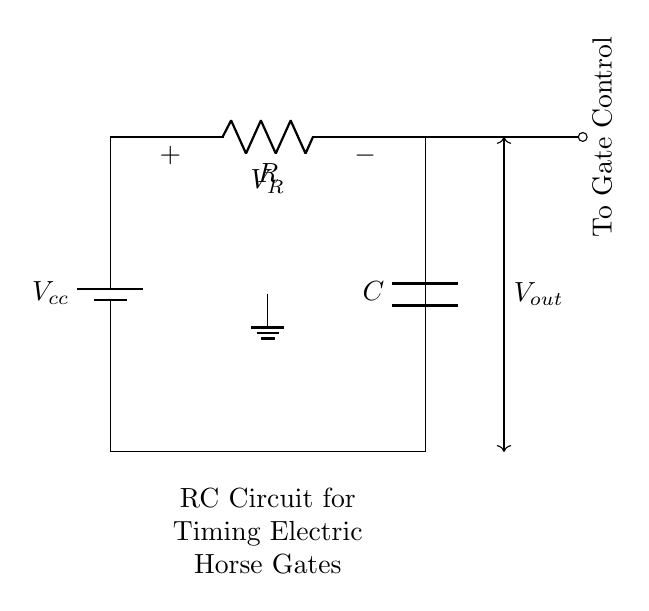What is the voltage source in this circuit? The circuit contains a battery labeled as Vcc, which provides the voltage for the circuit. It is clearly depicted as a vertical source at the left side of the diagram.
Answer: Vcc What component is used to control timing in this circuit? The capacitor labeled as C is used to store charge and control timing. In RC circuits, the capacitor discharges through the resistor, creating a timing effect.
Answer: C What is the voltage across the resistor? The voltage across the resistor is labeled as VR, indicating the voltage drop that occurs across that specific component when current flows through it.
Answer: VR What component connects to the gate control? The diagram shows a line labeled "To Gate Control" connected to the node after the resistor, indicating that this point connects to some control mechanism, likely to activate a gate.
Answer: Resistor How does the RC time constant affect the circuit? The time constant, given by the product of resistance and capacitance (RC), determines how quickly the capacitor charges and discharges. Shorter time constants result in quicker responses, while longer ones slow down the timing. The timing aspect is crucial for controlling the electric horse gates.
Answer: RC What is the purpose of the ground in this circuit? The ground, shown at the bottom of the circuit diagram, serves as a reference point for the electrical potential in the circuit. It completes the circuit pathway and ensures stable operation by providing a common return path for current.
Answer: Ground 